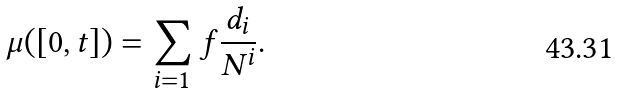Convert formula to latex. <formula><loc_0><loc_0><loc_500><loc_500>\mu ( [ 0 , t ] ) = \sum _ { i = 1 } ^ { \ } f \frac { d _ { i } } { N ^ { i } } .</formula> 